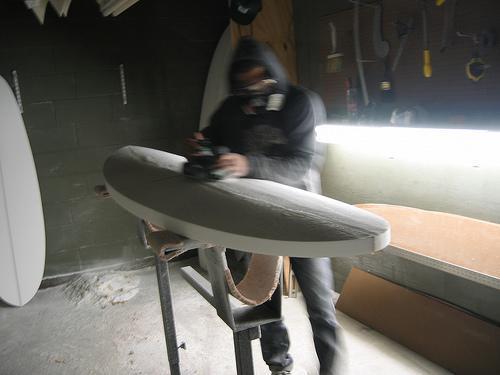How many people are in the picture?
Give a very brief answer. 1. 